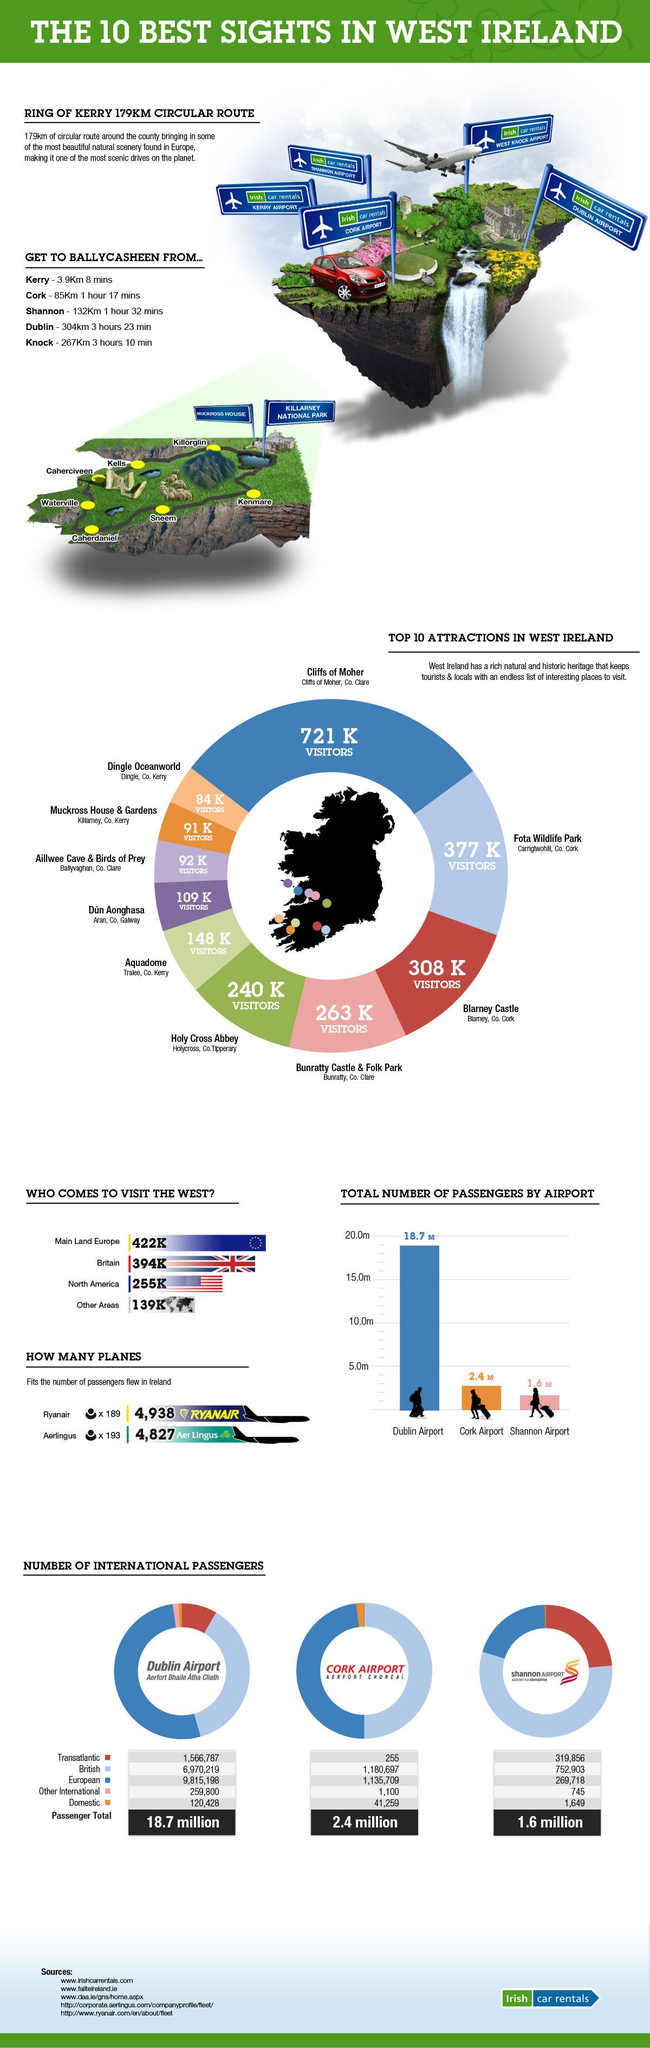Point out several critical features in this image. There are 5 airports located in West Ireland. In total, approximately 22.7 million passengers arrived through Dublin, Cork, and Shannon airports. The total number of domestic passengers in all three airports was 163,336. The color that denotes the second lowest number of visitors is orange. 